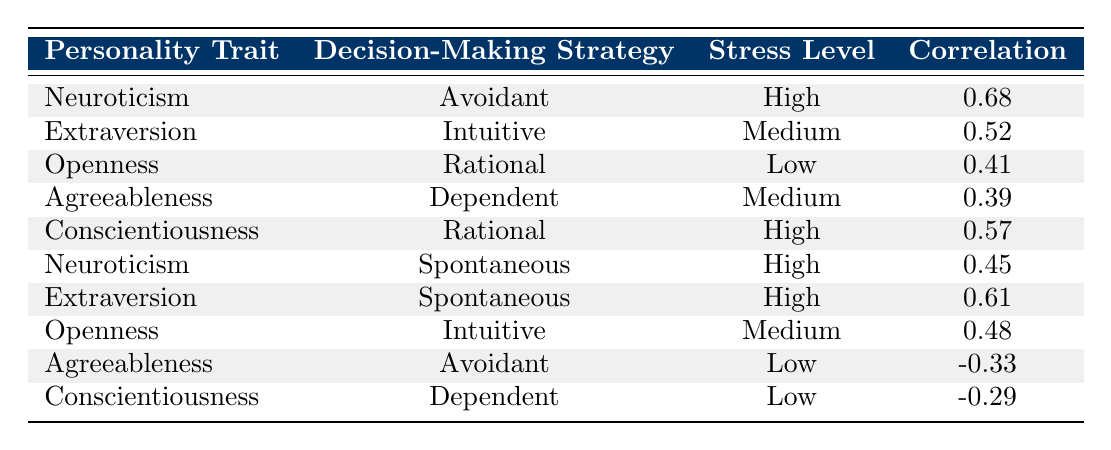What is the highest correlation observed in the table? The table shows several correlations between personality traits and decision-making strategies. Scanning through the correlation values, the highest correlation of 0.68 is found for Neuroticism and Avoidant strategy under high stress.
Answer: 0.68 Which personality trait is associated with the Rational decision-making strategy during low stress? Looking at the table, Openness is linked with the Rational decision-making strategy at a low stress level and has a correlation of 0.41.
Answer: Openness Is there a negative correlation for Agreeableness under low stress? The data shows that Agreeableness is paired with the Avoidant strategy at low stress, and the correlation value is -0.33, indicating a negative correlation.
Answer: Yes What is the correlation for Conscientiousness with the Rational strategy at high stress? By examining the relevant row for Conscientiousness and the Rational strategy at high stress, the table shows a correlation of 0.57.
Answer: 0.57 Which decision-making strategy is most strongly correlated with Neuroticism during high stress? For Neuroticism, two decision-making strategies are listed under high stress: Avoidant with a correlation of 0.68 and Spontaneous with a correlation of 0.45. The Avoidant strategy has the higher correlation.
Answer: Avoidant Calculate the average correlation for the strategies under high stress. The correlations for high stress are 0.68 (Neuroticism with Avoidant), 0.57 (Conscientiousness with Rational), and 0.45 (Neuroticism with Spontaneous). Summing these gives 0.68 + 0.57 + 0.45 = 1.70. There are three data points, so the average correlation is 1.70 / 3 ≈ 0.57.
Answer: Approximately 0.57 Which personality trait has a positive correlation with the Intuitive strategy at medium stress? The table indicates that Extraversion is associated with the Intuitive strategy at medium stress with a correlation of 0.52.
Answer: Extraversion Does Conscientiousness have a negative correlation with any strategy under low stress? The table reveals that Conscientiousness is paired with the Dependent strategy at low stress, showing a correlation of -0.29, which is negative.
Answer: Yes What is the correlation of Openness with the Intuitive strategy at medium stress? In the table, Openness and the Intuitive strategy correspond to a correlation of 0.48 when under medium stress.
Answer: 0.48 Determine which decision-making strategy has the lowest correlation with any personality trait under low stress. Reviewing the table for low stress correlations, Agreeableness with Avoidant has a correlation of -0.33 and Conscientiousness with Dependent has a correlation of -0.29. The Avoidant strategy has the lowest correlation.
Answer: Avoidant 